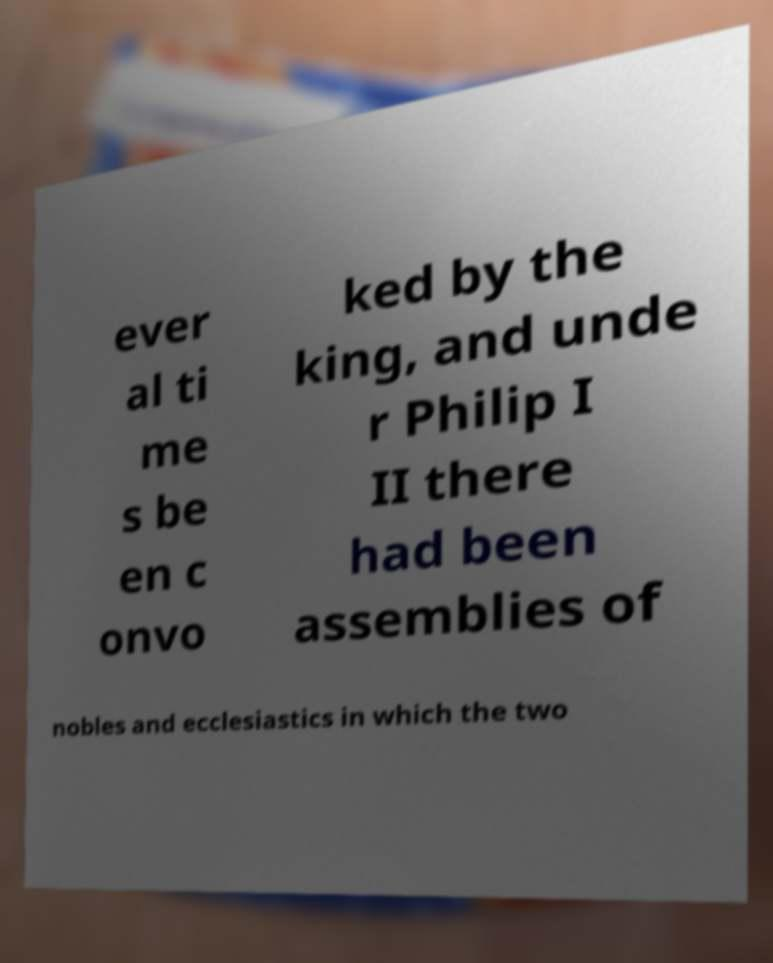Can you accurately transcribe the text from the provided image for me? ever al ti me s be en c onvo ked by the king, and unde r Philip I II there had been assemblies of nobles and ecclesiastics in which the two 